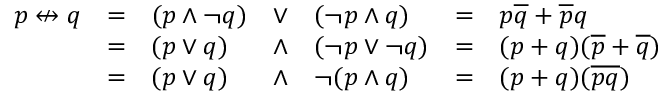<formula> <loc_0><loc_0><loc_500><loc_500>{ \begin{array} { l l l l l l l } { p \ n l e f t r i g h t a r r o w q } & { = } & { ( p \land \ln o t q ) } & { \lor } & { ( \ln o t p \land q ) } & { = } & { p { \overline { q } } + { \overline { p } } q } \\ & { = } & { ( p \lor q ) } & { \land } & { ( \ln o t p \lor \ln o t q ) } & { = } & { ( p + q ) ( { \overline { p } } + { \overline { q } } ) } \\ & { = } & { ( p \lor q ) } & { \land } & { \ln o t ( p \land q ) } & { = } & { ( p + q ) ( { \overline { p q } } ) } \end{array} }</formula> 